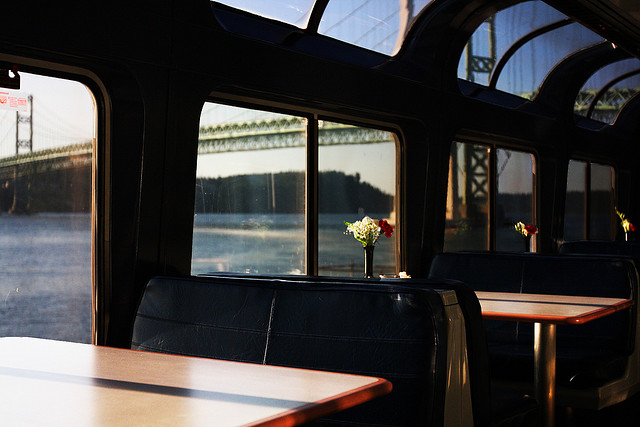<image>What is in front of the train? It is unknown what is in front of the train. It could be either a bridge or water. What is in front of the train? I don't know what is in front of the train. It can be seen a bridge, water or a window. 